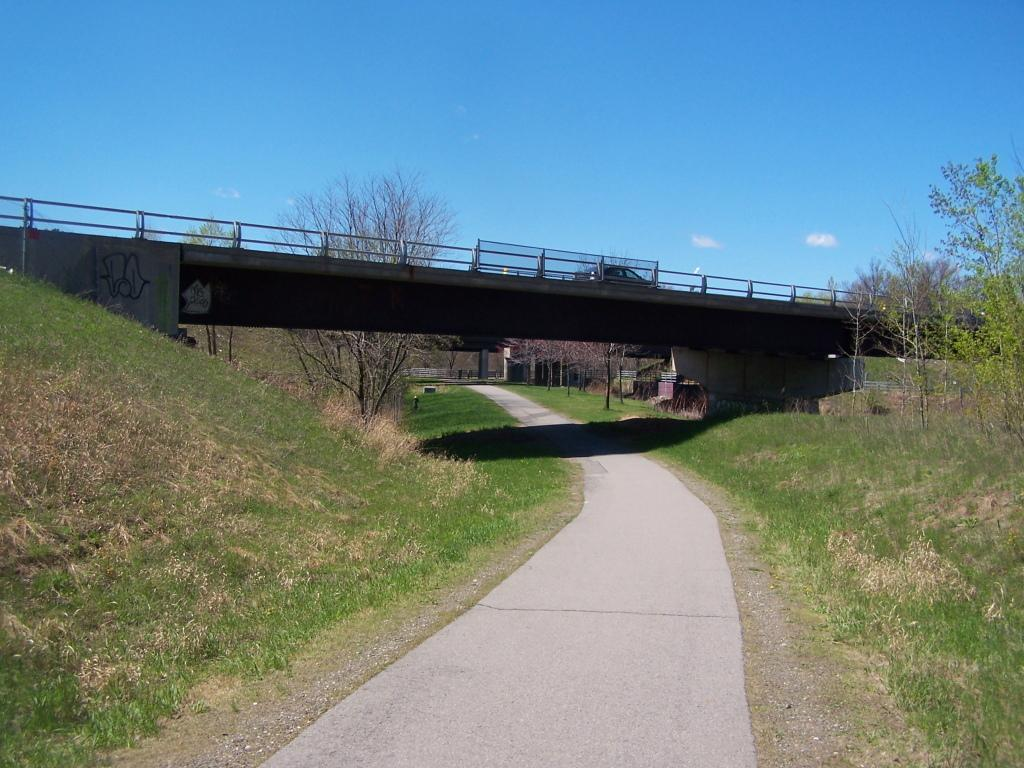What type of pathway is present in the image? There is a road in the image. What structure can be seen crossing over the road? There is a bridge in the image. What type of vegetation is present in the image? There is grass and trees in the image. What else can be seen in the image besides the road, bridge, grass, and trees? There are some objects in the image. What is visible in the background of the image? The sky is visible in the background of the image. Which direction is the robin flying in the image? There is no robin present in the image. How does the wind affect the objects in the image? There is no mention of wind in the image, so its effect on the objects cannot be determined. 